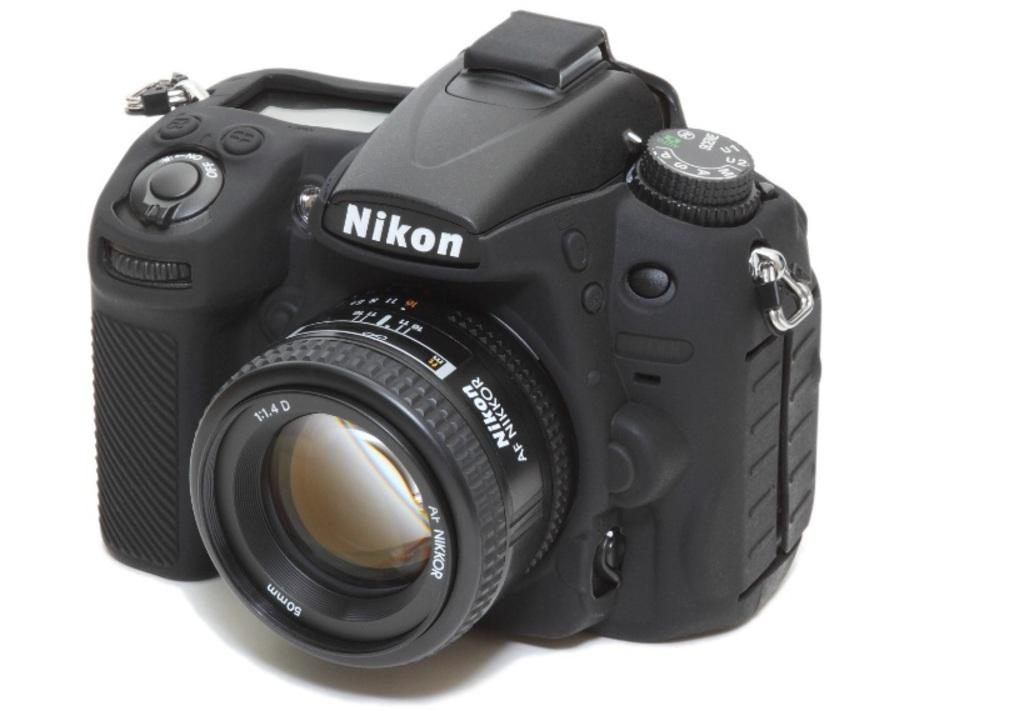What object is the main subject of the image? There is a camera in the image. What color is the camera? The camera is black in color. What color is the background of the image? The background of the image is white. How many icicles are hanging from the camera in the image? There are no icicles present in the image. What time does the clock on the camera display in the image? There is no clock present on the camera in the image. 